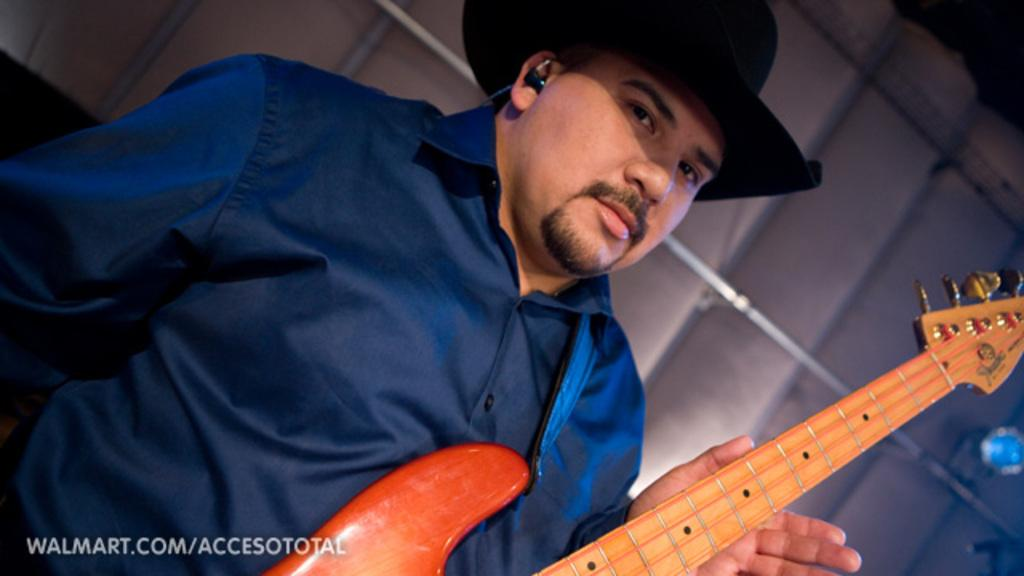What is the person in the image doing? The person is holding a guitar in the image. What object can be seen near the person? There is a metal rod visible in the image. Can you describe the unspecified object behind the person? Unfortunately, the facts provided do not give enough information to describe the object behind the person. What is written at the bottom of the image? There is some text at the bottom of the image. What type of beetle can be seen crawling on the bridge in the image? There is no beetle or bridge present in the image. Can you tell me the relationship between the person and the father in the image? There is no mention of a father in the image or the provided facts. 